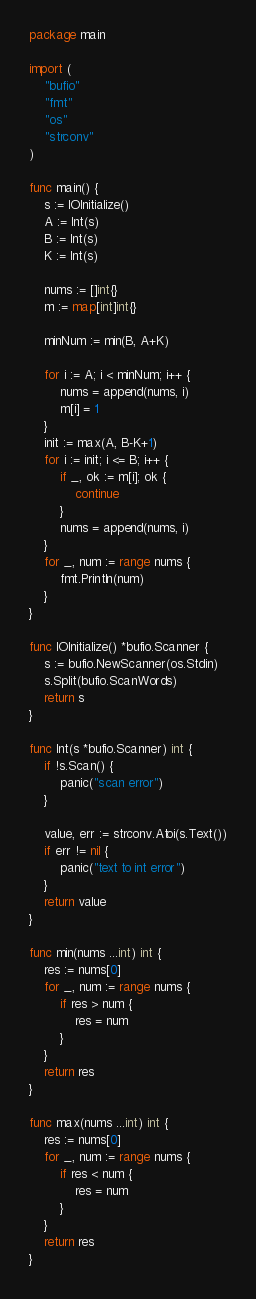Convert code to text. <code><loc_0><loc_0><loc_500><loc_500><_Go_>package main

import (
	"bufio"
	"fmt"
	"os"
	"strconv"
)

func main() {
	s := IOInitialize()
	A := Int(s)
	B := Int(s)
	K := Int(s)

	nums := []int{}
	m := map[int]int{}

	minNum := min(B, A+K)

	for i := A; i < minNum; i++ {
		nums = append(nums, i)
		m[i] = 1
	}
	init := max(A, B-K+1)
	for i := init; i <= B; i++ {
		if _, ok := m[i]; ok {
			continue
		}
		nums = append(nums, i)
	}
	for _, num := range nums {
		fmt.Println(num)
	}
}

func IOInitialize() *bufio.Scanner {
	s := bufio.NewScanner(os.Stdin)
	s.Split(bufio.ScanWords)
	return s
}

func Int(s *bufio.Scanner) int {
	if !s.Scan() {
		panic("scan error")
	}

	value, err := strconv.Atoi(s.Text())
	if err != nil {
		panic("text to int error")
	}
	return value
}

func min(nums ...int) int {
	res := nums[0]
	for _, num := range nums {
		if res > num {
			res = num
		}
	}
	return res
}

func max(nums ...int) int {
	res := nums[0]
	for _, num := range nums {
		if res < num {
			res = num
		}
	}
	return res
}</code> 